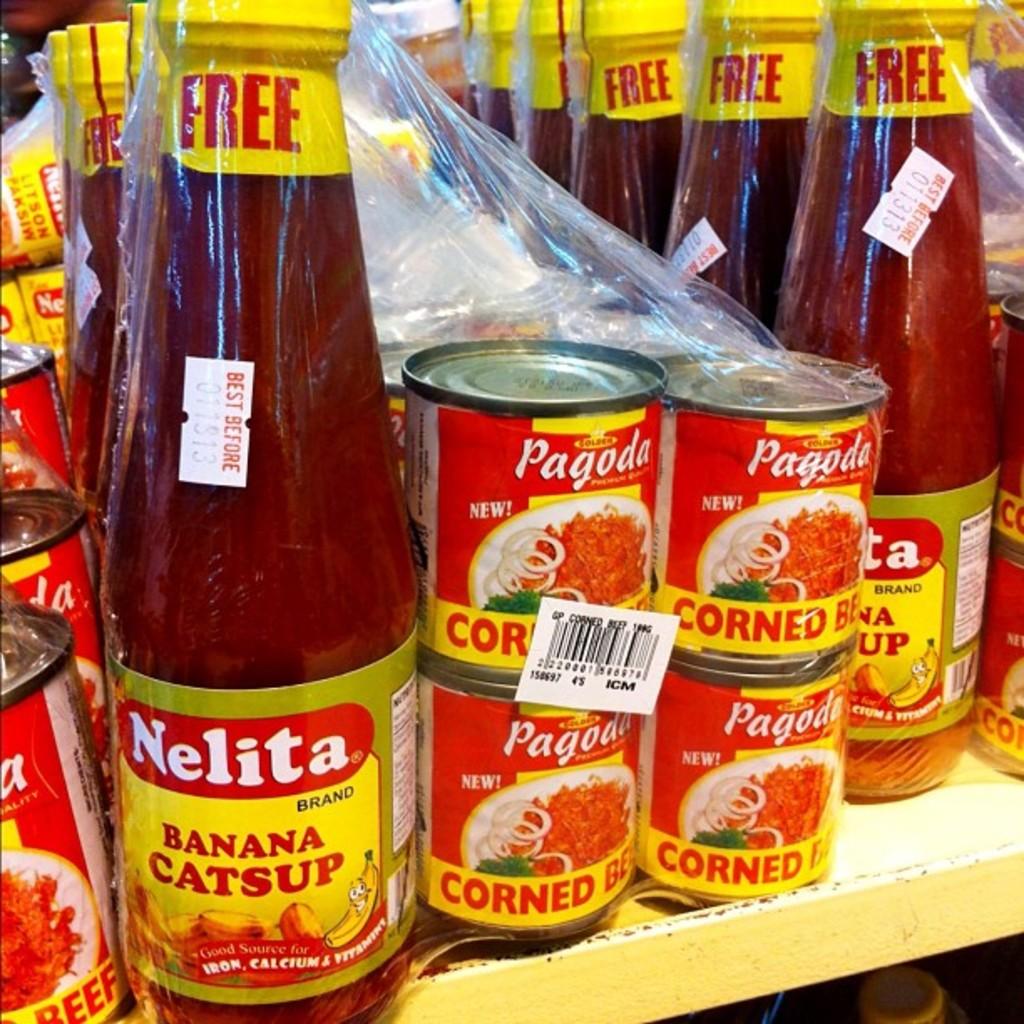What is the in the nelita bottle?
Your response must be concise. Banana catsup. What is the brand on the bottle?
Provide a succinct answer. Nelita. 